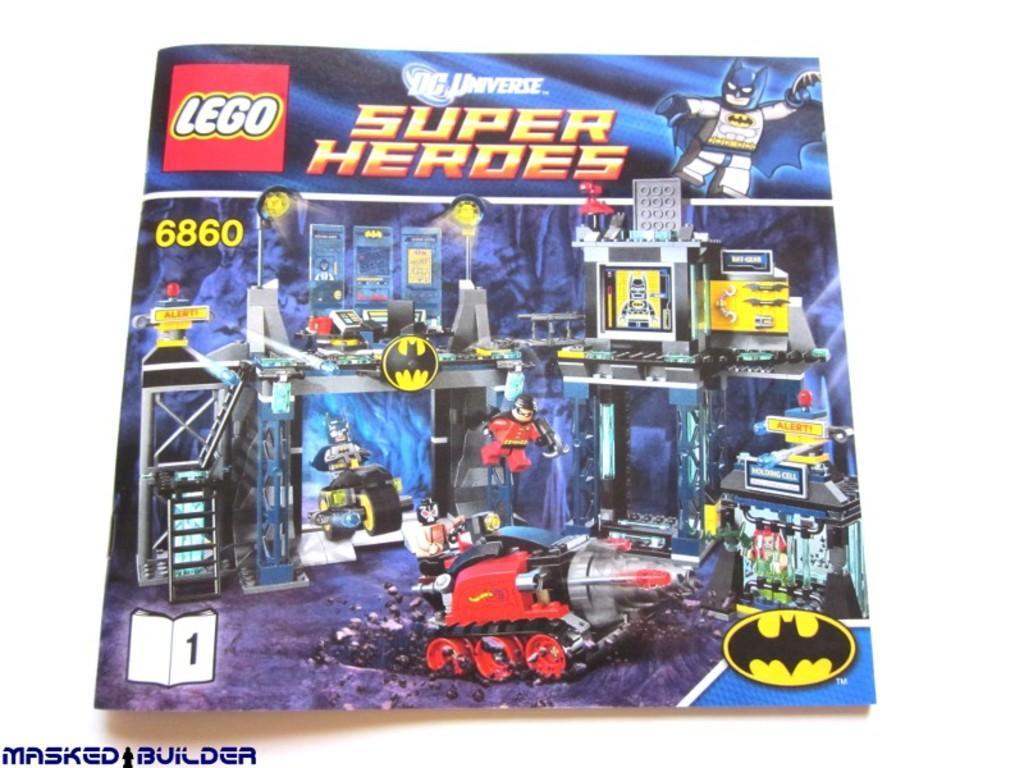Could you give a brief overview of what you see in this image? There is a poster. In that something is written and some animation images are there. Below that there is a watermark and in the background it is white. 